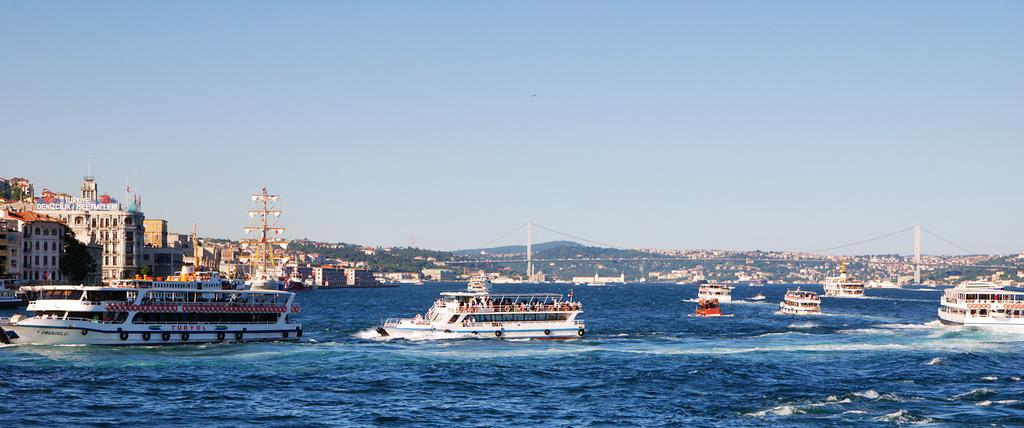What type of vehicles can be seen in the image? There are ships in the image. What structures are present in the image? There are buildings in the image. What decorative or symbolic items can be seen in the image? There are flags in the image. What type of vegetation is present in the image? There are trees in the image. What type of man-made structure connects two areas in the image? There is a bridge in the image. What is the color of the water in the image? The water in the image is blue-colored. What is the color of the sky in the image? The sky is blue in color. Where is the hydrant located in the image? There is no hydrant present in the image. Can you see any baseball players in the image? There are no baseball players or any reference to baseball in the image. 